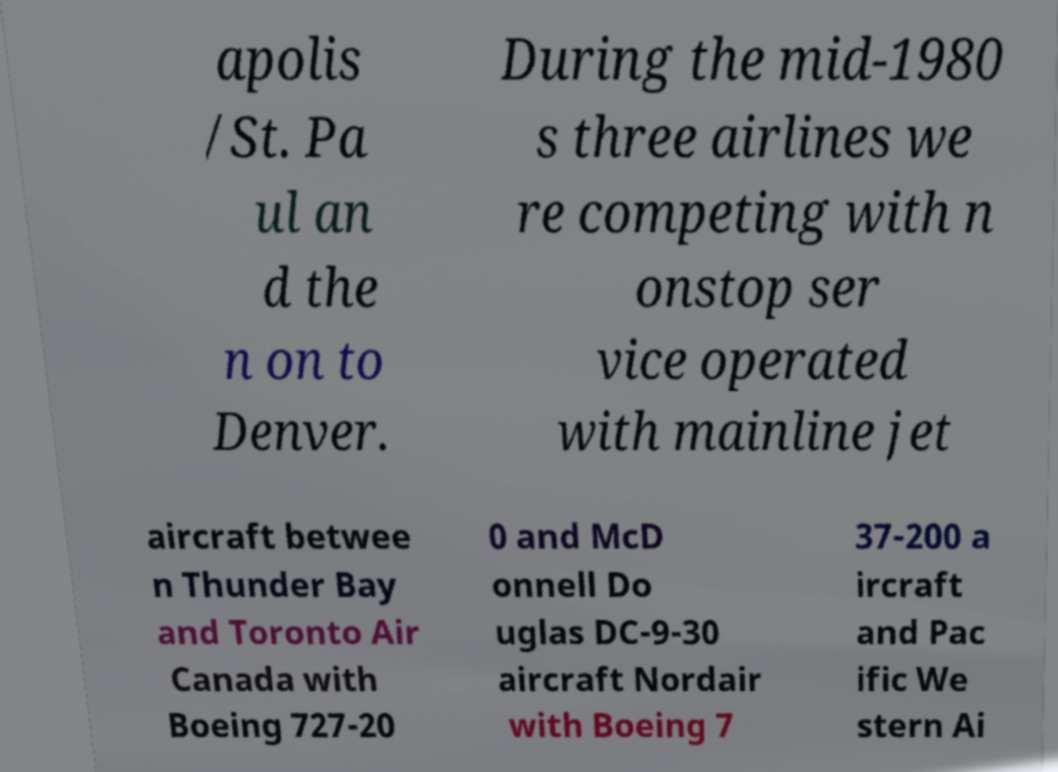I need the written content from this picture converted into text. Can you do that? apolis /St. Pa ul an d the n on to Denver. During the mid-1980 s three airlines we re competing with n onstop ser vice operated with mainline jet aircraft betwee n Thunder Bay and Toronto Air Canada with Boeing 727-20 0 and McD onnell Do uglas DC-9-30 aircraft Nordair with Boeing 7 37-200 a ircraft and Pac ific We stern Ai 